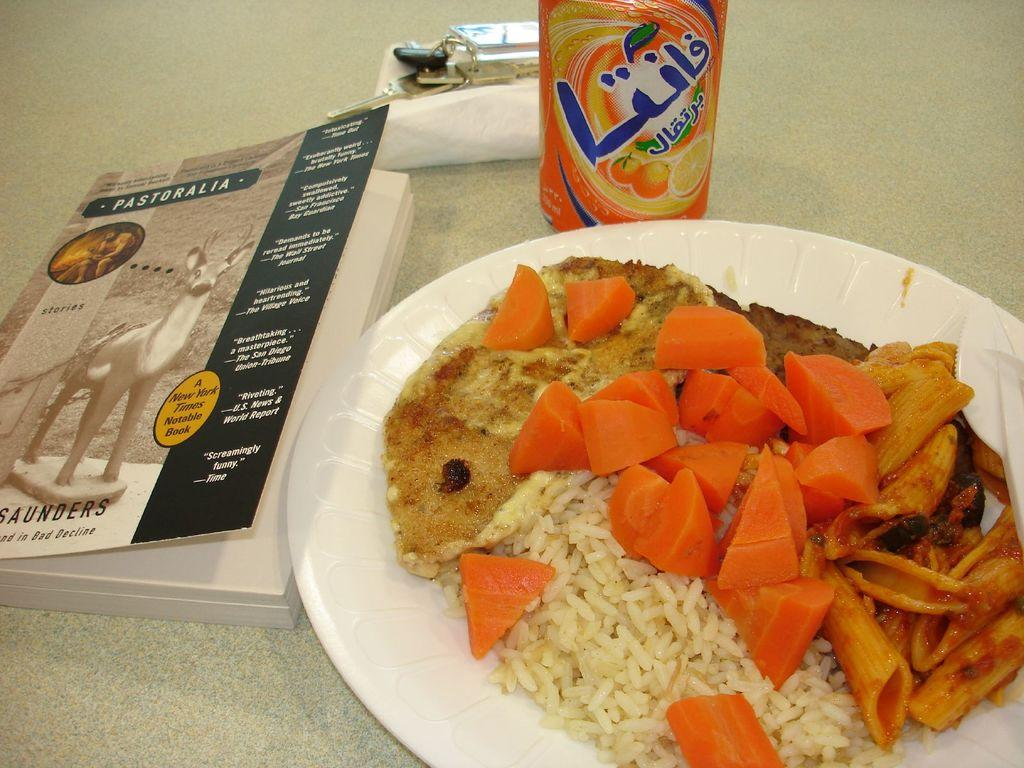What is on the white plate in the image? There is food on a white plate in the image. What other items can be seen in the image besides the plate? There is a tin, keys, a book, and other objects in the image. Where are these items placed? All these items are placed on a surface. How many fingers can be seen holding the bucket in the image? There is no bucket or fingers present in the image. Is there a giraffe visible in the image? No, there is no giraffe present in the image. 